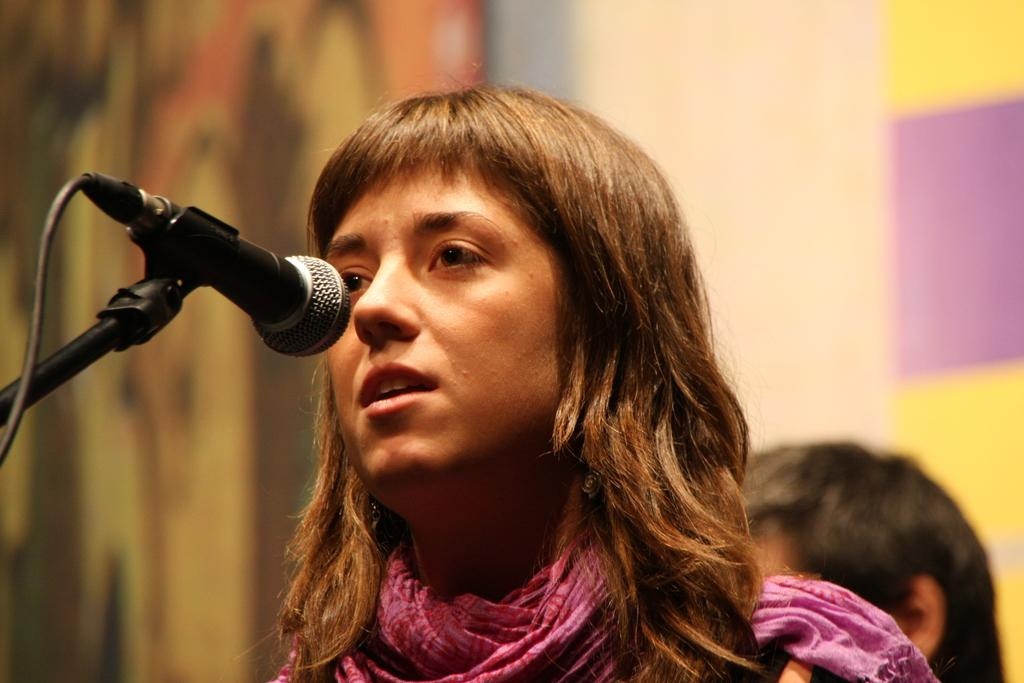Who is the main subject in the image? There is a woman in the image. What is the woman wearing? The woman is wearing a pink dress. What is the woman holding in the image? The woman is holding a microphone. Can you describe the microphone's appearance? The microphone is black and silver in color. What else can be seen in the background of the image? There is another person in the background of the image, and there are blurry surfaces. What type of paper is being used to support the ornament in the image? There is no paper or ornament present in the image. 